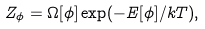Convert formula to latex. <formula><loc_0><loc_0><loc_500><loc_500>Z _ { \phi } = \Omega [ \phi ] \exp ( - E [ \phi ] / k T ) ,</formula> 